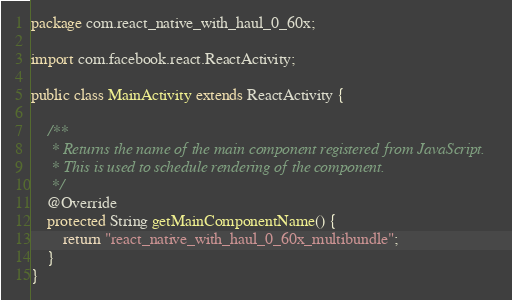<code> <loc_0><loc_0><loc_500><loc_500><_Java_>package com.react_native_with_haul_0_60x;

import com.facebook.react.ReactActivity;

public class MainActivity extends ReactActivity {

    /**
     * Returns the name of the main component registered from JavaScript.
     * This is used to schedule rendering of the component.
     */
    @Override
    protected String getMainComponentName() {
        return "react_native_with_haul_0_60x_multibundle";
    }
}
</code> 